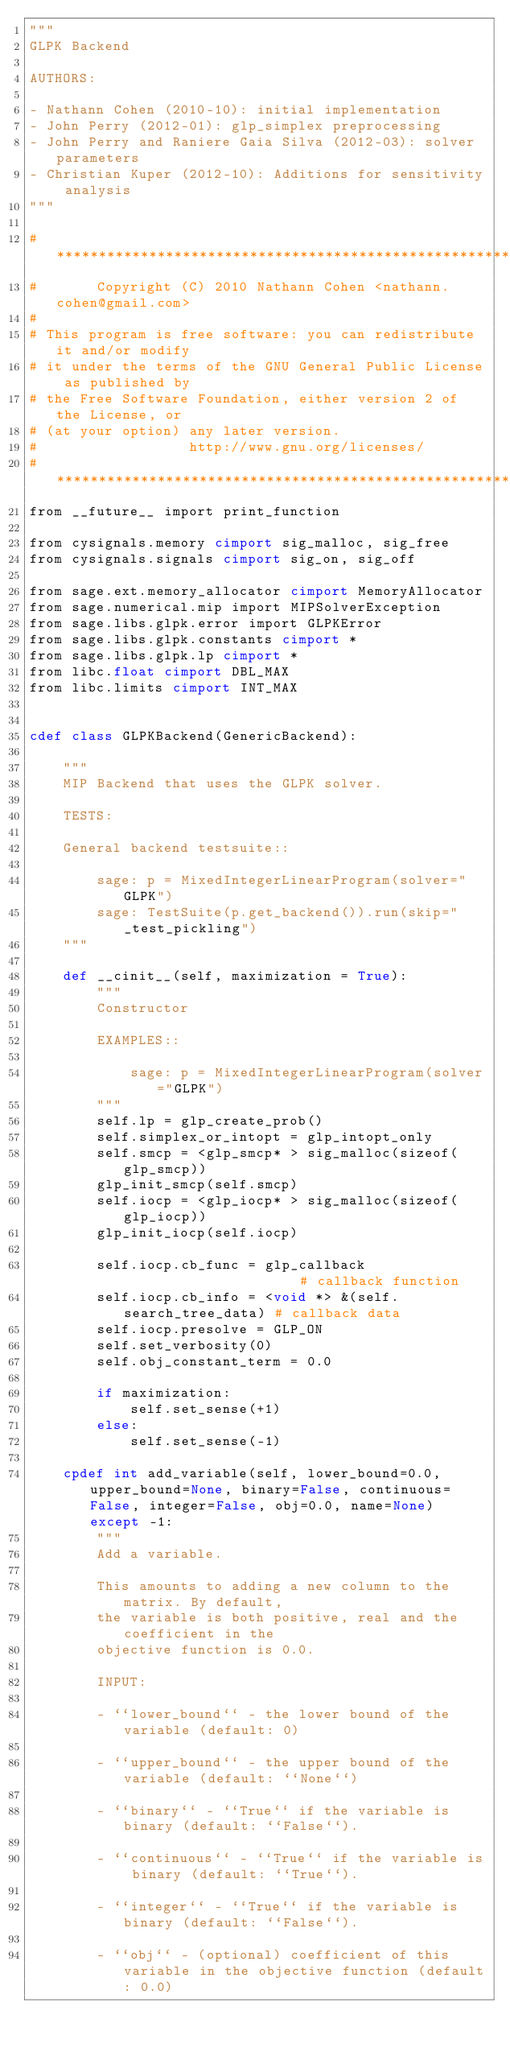<code> <loc_0><loc_0><loc_500><loc_500><_Cython_>"""
GLPK Backend

AUTHORS:

- Nathann Cohen (2010-10): initial implementation
- John Perry (2012-01): glp_simplex preprocessing
- John Perry and Raniere Gaia Silva (2012-03): solver parameters
- Christian Kuper (2012-10): Additions for sensitivity analysis
"""

#*****************************************************************************
#       Copyright (C) 2010 Nathann Cohen <nathann.cohen@gmail.com>
#
# This program is free software: you can redistribute it and/or modify
# it under the terms of the GNU General Public License as published by
# the Free Software Foundation, either version 2 of the License, or
# (at your option) any later version.
#                  http://www.gnu.org/licenses/
#*****************************************************************************
from __future__ import print_function

from cysignals.memory cimport sig_malloc, sig_free
from cysignals.signals cimport sig_on, sig_off

from sage.ext.memory_allocator cimport MemoryAllocator
from sage.numerical.mip import MIPSolverException
from sage.libs.glpk.error import GLPKError
from sage.libs.glpk.constants cimport *
from sage.libs.glpk.lp cimport *
from libc.float cimport DBL_MAX
from libc.limits cimport INT_MAX


cdef class GLPKBackend(GenericBackend):

    """
    MIP Backend that uses the GLPK solver.

    TESTS:

    General backend testsuite::

        sage: p = MixedIntegerLinearProgram(solver="GLPK")
        sage: TestSuite(p.get_backend()).run(skip="_test_pickling")
    """

    def __cinit__(self, maximization = True):
        """
        Constructor

        EXAMPLES::

            sage: p = MixedIntegerLinearProgram(solver="GLPK")
        """
        self.lp = glp_create_prob()
        self.simplex_or_intopt = glp_intopt_only
        self.smcp = <glp_smcp* > sig_malloc(sizeof(glp_smcp))
        glp_init_smcp(self.smcp)
        self.iocp = <glp_iocp* > sig_malloc(sizeof(glp_iocp))
        glp_init_iocp(self.iocp)

        self.iocp.cb_func = glp_callback                      # callback function
        self.iocp.cb_info = <void *> &(self.search_tree_data) # callback data
        self.iocp.presolve = GLP_ON
        self.set_verbosity(0)
        self.obj_constant_term = 0.0

        if maximization:
            self.set_sense(+1)
        else:
            self.set_sense(-1)

    cpdef int add_variable(self, lower_bound=0.0, upper_bound=None, binary=False, continuous=False, integer=False, obj=0.0, name=None) except -1:
        """
        Add a variable.

        This amounts to adding a new column to the matrix. By default,
        the variable is both positive, real and the coefficient in the
        objective function is 0.0.

        INPUT:

        - ``lower_bound`` - the lower bound of the variable (default: 0)

        - ``upper_bound`` - the upper bound of the variable (default: ``None``)

        - ``binary`` - ``True`` if the variable is binary (default: ``False``).

        - ``continuous`` - ``True`` if the variable is binary (default: ``True``).

        - ``integer`` - ``True`` if the variable is binary (default: ``False``).

        - ``obj`` - (optional) coefficient of this variable in the objective function (default: 0.0)
</code> 